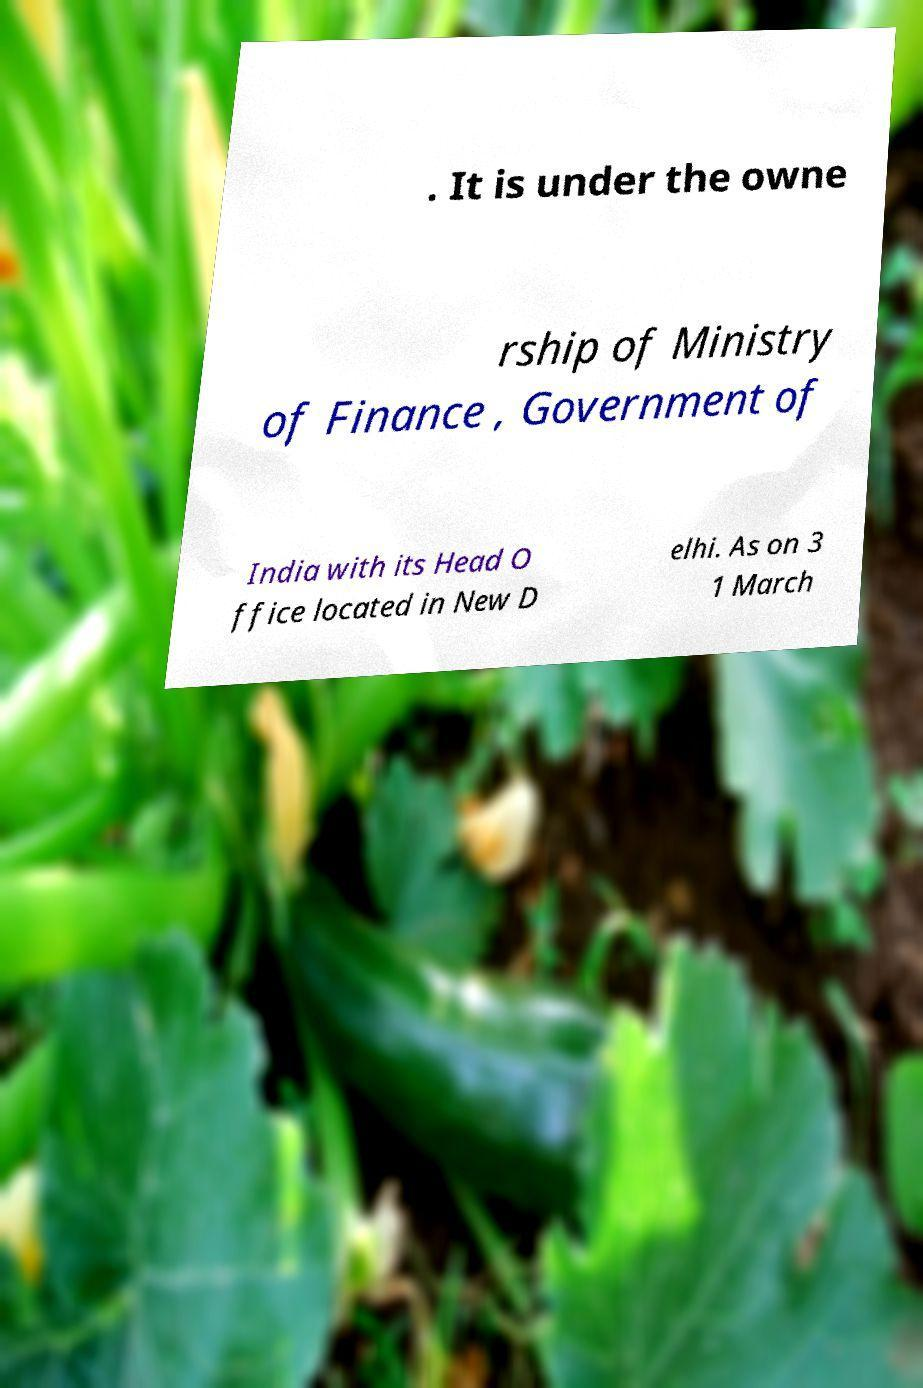Could you extract and type out the text from this image? . It is under the owne rship of Ministry of Finance , Government of India with its Head O ffice located in New D elhi. As on 3 1 March 